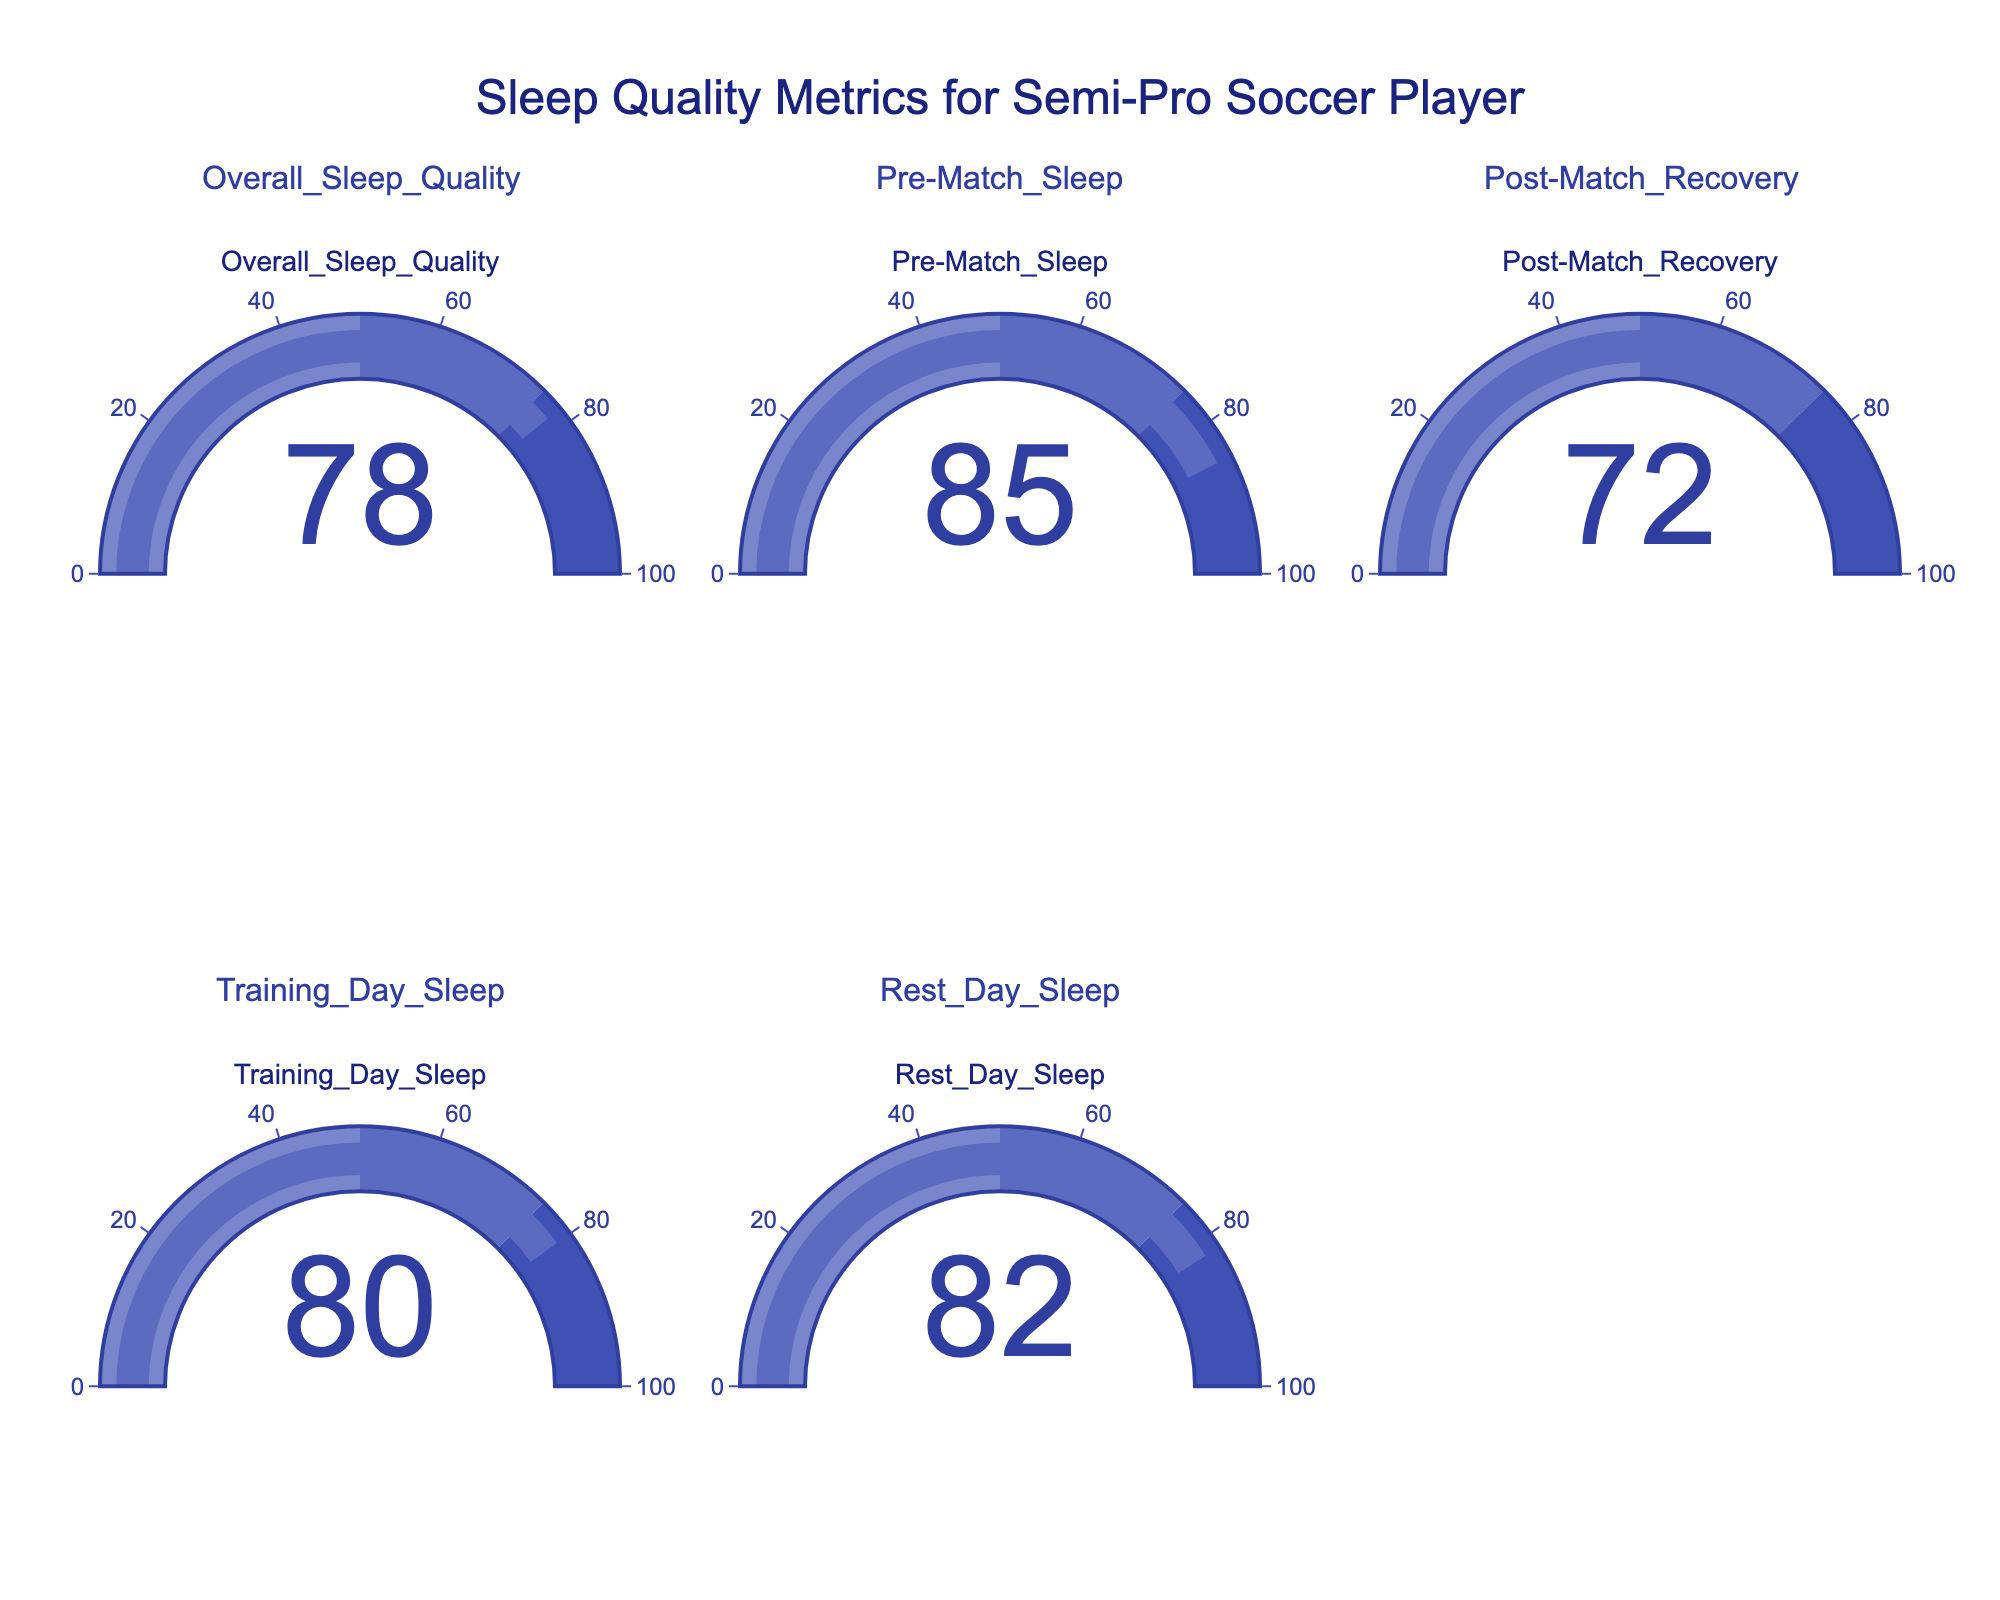What is the title of the figure? The title is usually found at the top of the figure. Here, it reads: "Sleep Quality Metrics for Semi-Pro Soccer Player"
Answer: Sleep Quality Metrics for Semi-Pro Soccer Player What is the score for Pre-Match Sleep? The Pre-Match Sleep gauge displays a number, which is the score for this metric. In this figure, the number is 85
Answer: 85 Which sleep metric has the highest score? By examining all the gauges, we identify the highest value displayed. Pre-Match Sleep has the highest score: 85
Answer: Pre-Match Sleep Which two metrics have the closest scores? Checking the scores displayed on each gauge, Training Day Sleep (80) and Rest Day Sleep (82) are closest, with a difference of 2 points
Answer: Training Day Sleep and Rest Day Sleep What is the difference between the highest and lowest scores? Identify the highest score (85 for Pre-Match Sleep) and the lowest score (72 for Post-Match Recovery). The difference is calculated as 85 - 72
Answer: 13 What color represents scores in the range of 50 to 75? The gauge ranges are color-coded. For scores between 50 and 75, it covers the second range, which is colored in the lighter blue indicated in the gauge steps.
Answer: Light blue What is the average score of all metrics displayed? Sum all the scores (78 + 85 + 72 + 80 + 82) = 397, then divide by the number of metrics (5). The average score is 397 / 5
Answer: 79.4 How many metrics have scores above 80? Counting the gauges with scores greater than 80: Pre-Match Sleep (85) and Rest Day Sleep (82) gives a total of 2
Answer: 2 Which metric has the lowest score? By examining all the gauges, the lowest value displayed is 72 for Post-Match Recovery
Answer: Post-Match Recovery 